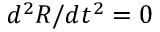Convert formula to latex. <formula><loc_0><loc_0><loc_500><loc_500>d ^ { 2 } R / d t ^ { 2 } = 0</formula> 